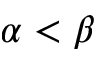<formula> <loc_0><loc_0><loc_500><loc_500>\alpha < \beta</formula> 